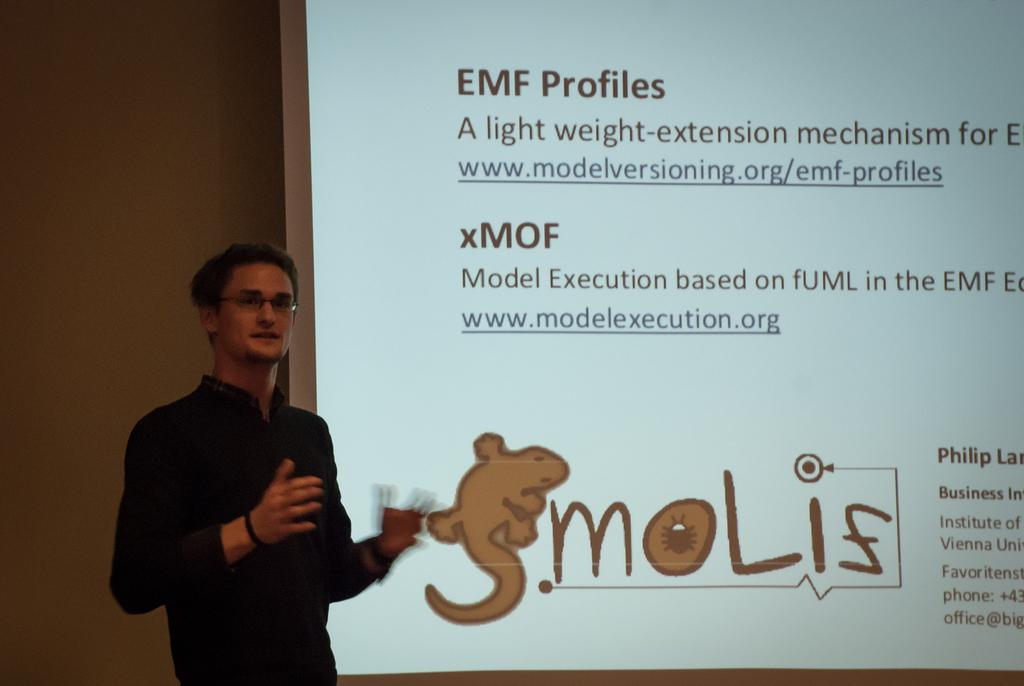What is located at the left side of the image? There is a person standing at the left side of the image. What is the person wearing? The person is wearing a black shirt. What can be seen in the image besides the person? There is a projector display visible in the image. Can you see any cracks in the person's black shirt in the image? There are no visible cracks in the person's black shirt in the image. What type of cub is present in the image? There is no cub present in the image. 